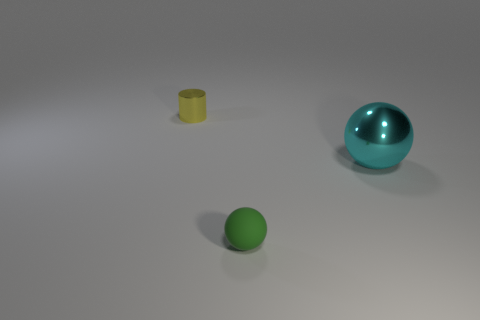Add 2 green metal cylinders. How many objects exist? 5 Subtract all balls. How many objects are left? 1 Subtract 0 yellow spheres. How many objects are left? 3 Subtract all big purple things. Subtract all tiny objects. How many objects are left? 1 Add 3 tiny yellow metal objects. How many tiny yellow metal objects are left? 4 Add 3 shiny cylinders. How many shiny cylinders exist? 4 